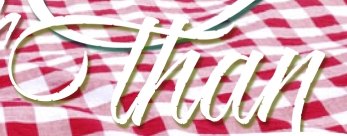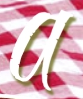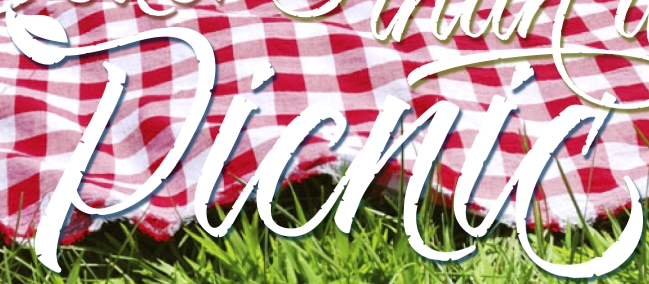Identify the words shown in these images in order, separated by a semicolon. than; a; Picnic 